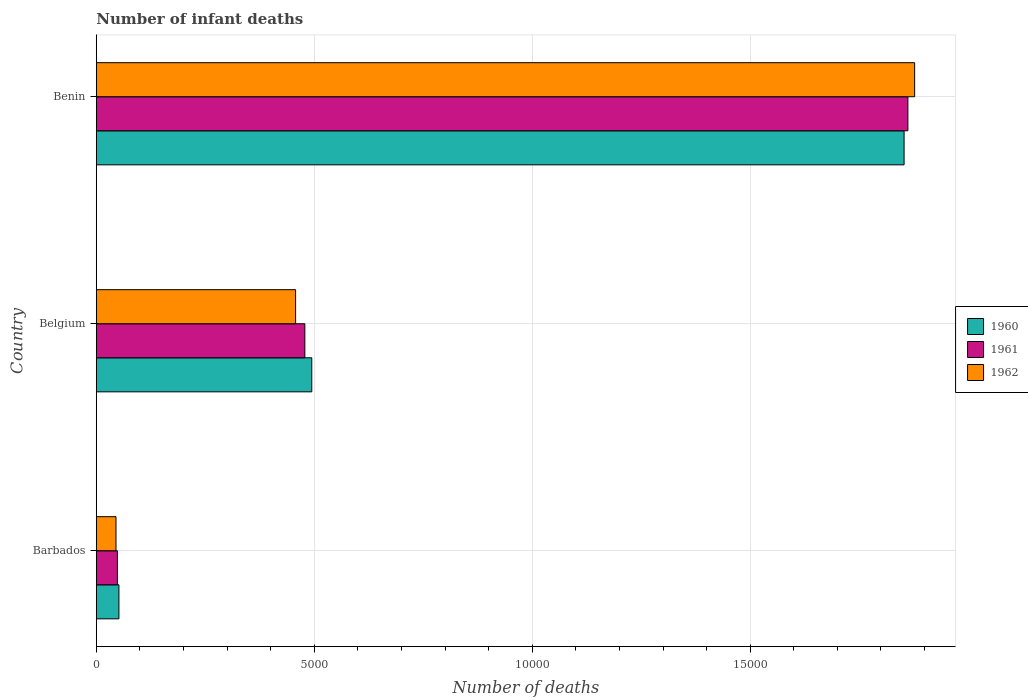How many bars are there on the 2nd tick from the top?
Give a very brief answer. 3. What is the label of the 1st group of bars from the top?
Give a very brief answer. Benin. What is the number of infant deaths in 1960 in Belgium?
Make the answer very short. 4942. Across all countries, what is the maximum number of infant deaths in 1962?
Give a very brief answer. 1.88e+04. Across all countries, what is the minimum number of infant deaths in 1961?
Make the answer very short. 483. In which country was the number of infant deaths in 1960 maximum?
Offer a very short reply. Benin. In which country was the number of infant deaths in 1962 minimum?
Make the answer very short. Barbados. What is the total number of infant deaths in 1961 in the graph?
Your answer should be compact. 2.39e+04. What is the difference between the number of infant deaths in 1961 in Barbados and that in Belgium?
Provide a succinct answer. -4300. What is the difference between the number of infant deaths in 1960 in Barbados and the number of infant deaths in 1962 in Benin?
Your answer should be very brief. -1.83e+04. What is the average number of infant deaths in 1960 per country?
Keep it short and to the point. 7996.67. What is the difference between the number of infant deaths in 1962 and number of infant deaths in 1960 in Belgium?
Offer a terse response. -371. In how many countries, is the number of infant deaths in 1960 greater than 8000 ?
Keep it short and to the point. 1. What is the ratio of the number of infant deaths in 1962 in Belgium to that in Benin?
Ensure brevity in your answer.  0.24. Is the difference between the number of infant deaths in 1962 in Barbados and Belgium greater than the difference between the number of infant deaths in 1960 in Barbados and Belgium?
Keep it short and to the point. Yes. What is the difference between the highest and the second highest number of infant deaths in 1962?
Offer a terse response. 1.42e+04. What is the difference between the highest and the lowest number of infant deaths in 1960?
Give a very brief answer. 1.80e+04. What does the 1st bar from the top in Benin represents?
Give a very brief answer. 1962. What does the 2nd bar from the bottom in Barbados represents?
Provide a short and direct response. 1961. Is it the case that in every country, the sum of the number of infant deaths in 1961 and number of infant deaths in 1960 is greater than the number of infant deaths in 1962?
Make the answer very short. Yes. How many bars are there?
Provide a short and direct response. 9. Are all the bars in the graph horizontal?
Offer a very short reply. Yes. Does the graph contain grids?
Provide a short and direct response. Yes. Where does the legend appear in the graph?
Provide a short and direct response. Center right. How many legend labels are there?
Offer a terse response. 3. What is the title of the graph?
Offer a very short reply. Number of infant deaths. Does "1999" appear as one of the legend labels in the graph?
Offer a terse response. No. What is the label or title of the X-axis?
Give a very brief answer. Number of deaths. What is the Number of deaths in 1960 in Barbados?
Your answer should be compact. 518. What is the Number of deaths of 1961 in Barbados?
Provide a succinct answer. 483. What is the Number of deaths in 1962 in Barbados?
Provide a succinct answer. 451. What is the Number of deaths of 1960 in Belgium?
Give a very brief answer. 4942. What is the Number of deaths of 1961 in Belgium?
Ensure brevity in your answer.  4783. What is the Number of deaths of 1962 in Belgium?
Provide a succinct answer. 4571. What is the Number of deaths in 1960 in Benin?
Your answer should be very brief. 1.85e+04. What is the Number of deaths of 1961 in Benin?
Offer a very short reply. 1.86e+04. What is the Number of deaths of 1962 in Benin?
Ensure brevity in your answer.  1.88e+04. Across all countries, what is the maximum Number of deaths in 1960?
Your answer should be compact. 1.85e+04. Across all countries, what is the maximum Number of deaths of 1961?
Ensure brevity in your answer.  1.86e+04. Across all countries, what is the maximum Number of deaths of 1962?
Your response must be concise. 1.88e+04. Across all countries, what is the minimum Number of deaths in 1960?
Ensure brevity in your answer.  518. Across all countries, what is the minimum Number of deaths of 1961?
Ensure brevity in your answer.  483. Across all countries, what is the minimum Number of deaths of 1962?
Your answer should be very brief. 451. What is the total Number of deaths of 1960 in the graph?
Keep it short and to the point. 2.40e+04. What is the total Number of deaths of 1961 in the graph?
Your response must be concise. 2.39e+04. What is the total Number of deaths in 1962 in the graph?
Make the answer very short. 2.38e+04. What is the difference between the Number of deaths in 1960 in Barbados and that in Belgium?
Ensure brevity in your answer.  -4424. What is the difference between the Number of deaths in 1961 in Barbados and that in Belgium?
Give a very brief answer. -4300. What is the difference between the Number of deaths in 1962 in Barbados and that in Belgium?
Offer a very short reply. -4120. What is the difference between the Number of deaths of 1960 in Barbados and that in Benin?
Ensure brevity in your answer.  -1.80e+04. What is the difference between the Number of deaths in 1961 in Barbados and that in Benin?
Ensure brevity in your answer.  -1.81e+04. What is the difference between the Number of deaths in 1962 in Barbados and that in Benin?
Keep it short and to the point. -1.83e+04. What is the difference between the Number of deaths of 1960 in Belgium and that in Benin?
Your answer should be compact. -1.36e+04. What is the difference between the Number of deaths in 1961 in Belgium and that in Benin?
Make the answer very short. -1.38e+04. What is the difference between the Number of deaths in 1962 in Belgium and that in Benin?
Your response must be concise. -1.42e+04. What is the difference between the Number of deaths of 1960 in Barbados and the Number of deaths of 1961 in Belgium?
Offer a terse response. -4265. What is the difference between the Number of deaths of 1960 in Barbados and the Number of deaths of 1962 in Belgium?
Your response must be concise. -4053. What is the difference between the Number of deaths of 1961 in Barbados and the Number of deaths of 1962 in Belgium?
Provide a short and direct response. -4088. What is the difference between the Number of deaths in 1960 in Barbados and the Number of deaths in 1961 in Benin?
Make the answer very short. -1.81e+04. What is the difference between the Number of deaths of 1960 in Barbados and the Number of deaths of 1962 in Benin?
Your answer should be very brief. -1.83e+04. What is the difference between the Number of deaths of 1961 in Barbados and the Number of deaths of 1962 in Benin?
Make the answer very short. -1.83e+04. What is the difference between the Number of deaths of 1960 in Belgium and the Number of deaths of 1961 in Benin?
Provide a succinct answer. -1.37e+04. What is the difference between the Number of deaths in 1960 in Belgium and the Number of deaths in 1962 in Benin?
Your answer should be very brief. -1.38e+04. What is the difference between the Number of deaths in 1961 in Belgium and the Number of deaths in 1962 in Benin?
Provide a short and direct response. -1.40e+04. What is the average Number of deaths in 1960 per country?
Offer a terse response. 7996.67. What is the average Number of deaths of 1961 per country?
Keep it short and to the point. 7961. What is the average Number of deaths in 1962 per country?
Provide a succinct answer. 7931.33. What is the difference between the Number of deaths in 1960 and Number of deaths in 1961 in Barbados?
Provide a succinct answer. 35. What is the difference between the Number of deaths in 1961 and Number of deaths in 1962 in Barbados?
Make the answer very short. 32. What is the difference between the Number of deaths of 1960 and Number of deaths of 1961 in Belgium?
Your answer should be compact. 159. What is the difference between the Number of deaths of 1960 and Number of deaths of 1962 in Belgium?
Your response must be concise. 371. What is the difference between the Number of deaths of 1961 and Number of deaths of 1962 in Belgium?
Give a very brief answer. 212. What is the difference between the Number of deaths of 1960 and Number of deaths of 1961 in Benin?
Offer a very short reply. -87. What is the difference between the Number of deaths in 1960 and Number of deaths in 1962 in Benin?
Give a very brief answer. -242. What is the difference between the Number of deaths in 1961 and Number of deaths in 1962 in Benin?
Provide a succinct answer. -155. What is the ratio of the Number of deaths of 1960 in Barbados to that in Belgium?
Provide a short and direct response. 0.1. What is the ratio of the Number of deaths of 1961 in Barbados to that in Belgium?
Keep it short and to the point. 0.1. What is the ratio of the Number of deaths in 1962 in Barbados to that in Belgium?
Keep it short and to the point. 0.1. What is the ratio of the Number of deaths in 1960 in Barbados to that in Benin?
Your answer should be compact. 0.03. What is the ratio of the Number of deaths of 1961 in Barbados to that in Benin?
Your response must be concise. 0.03. What is the ratio of the Number of deaths of 1962 in Barbados to that in Benin?
Ensure brevity in your answer.  0.02. What is the ratio of the Number of deaths in 1960 in Belgium to that in Benin?
Provide a short and direct response. 0.27. What is the ratio of the Number of deaths of 1961 in Belgium to that in Benin?
Offer a very short reply. 0.26. What is the ratio of the Number of deaths of 1962 in Belgium to that in Benin?
Provide a succinct answer. 0.24. What is the difference between the highest and the second highest Number of deaths of 1960?
Provide a succinct answer. 1.36e+04. What is the difference between the highest and the second highest Number of deaths in 1961?
Provide a short and direct response. 1.38e+04. What is the difference between the highest and the second highest Number of deaths of 1962?
Give a very brief answer. 1.42e+04. What is the difference between the highest and the lowest Number of deaths in 1960?
Your response must be concise. 1.80e+04. What is the difference between the highest and the lowest Number of deaths in 1961?
Offer a terse response. 1.81e+04. What is the difference between the highest and the lowest Number of deaths of 1962?
Ensure brevity in your answer.  1.83e+04. 